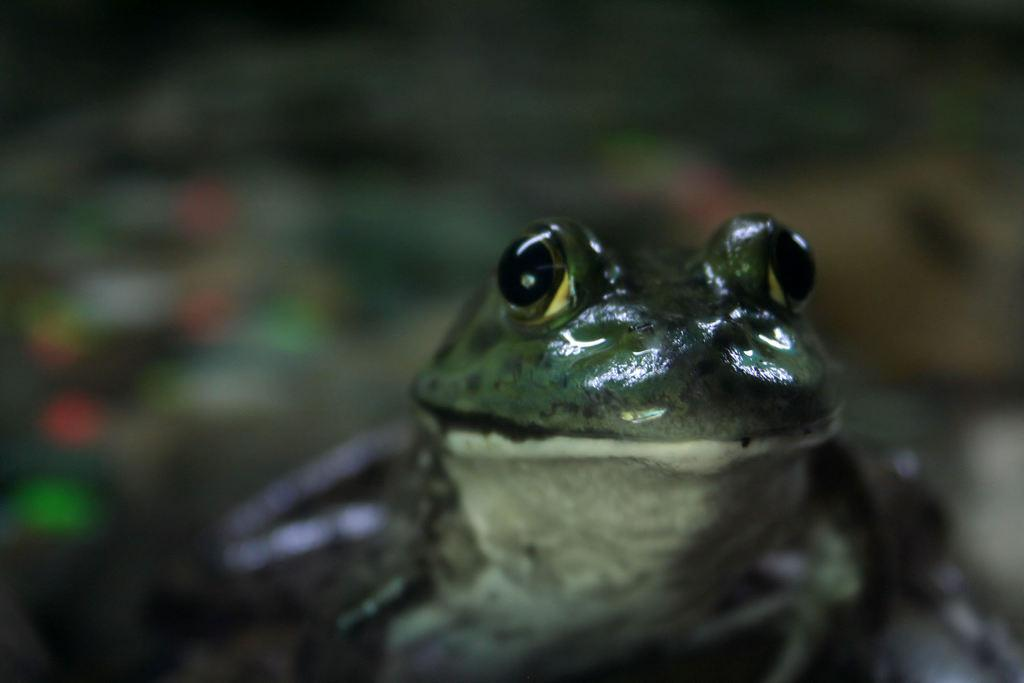What animal is in the picture? There is a frog in the picture. What is the frog doing in the picture? The frog is looking at the camera. Can you describe the background of the image? The background of the image is blurred. What type of window can be seen in the image? There is no window present in the image; it features a frog looking at the camera with a blurred background. 